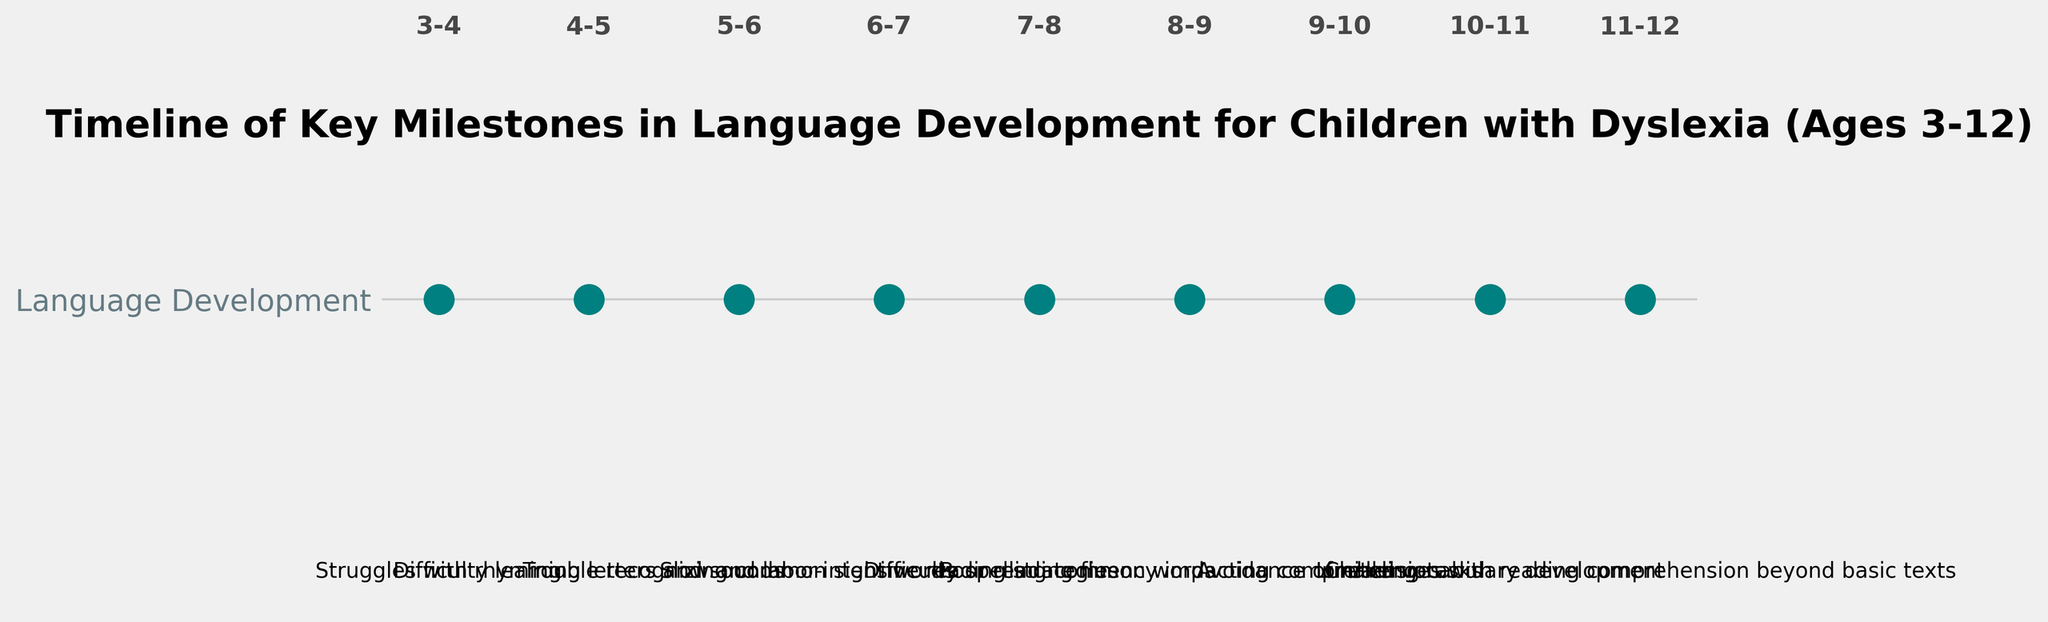When do children with dyslexia typically start struggling with rhyming? The figure shows that children with dyslexia usually start struggling with rhyming between the ages of 3 and 4. This is indicated by the milestone marker at the 3-4 age range.
Answer: Between ages 3-4 At what age do children with dyslexia commonly have difficulty learning letters and sounds? According to the figure, children with dyslexia often face issues learning letters and sounds between the ages of 4 and 5. The milestone for this is marked at the 4-5 age range.
Answer: Between ages 4-5 Which milestone related to reading strategies appears first on the timeline? The figure specifies a milestone referring to "slow and labor-intensive reading strategies" at the age range of 6-7, which is the first mention of reading strategies in the timeline.
Answer: Age 6-7 What is the primary reading challenge for children with dyslexia between ages 9 and 10, according to the timeline? The figure indicates that children with dyslexia primarily experience "Avoidance of reading tasks" between the ages of 9 and 10, as shown by the milestone for this age range.
Answer: Avoidance of reading tasks Compare the complexity of reading comprehension challenges between ages 8-9 and 11-12. The figure shows that from ages 8-9, children with dyslexia have "Poor reading fluency impacting comprehension," whereas from ages 11-12, they encounter "Challenges with reading comprehension beyond basic texts." The latter suggests a more advanced level of difficulty as it affects higher-level comprehension beyond basics.
Answer: More advanced at ages 11-12 How do the milestones relate to vocabulary development as per the timeline, and at what age does this occur? The timeline in the figure indicates that children with dyslexia face "Limited vocabulary development" at ages 10-11, highlighting a developmental milestone where vocabulary growth is particularly affected.
Answer: Age 10-11 Identify the milestone directly associated with difficulties in recognizing common sight words and indicate the relevant age range. The figure shows that the milestone "Trouble recognizing common sight words" is marked for children aged 5-6, indicating this age range for the associated difficulty.
Answer: Age 5-6 What visual cue is used to indicate milestones on the timeline, and how consistently are they placed? The milestones on the timeline are indicated using teal-colored circles (markers), and they are consistently placed along a single horizontal line representing language development milestones.
Answer: Teal circles, consistently on one line What does the milestone at ages 7-8 signify in the context of language development for children with dyslexia? According to the figure, the milestone at ages 7-8 signifies "Difficulty spelling common words," indicating a specific challenge in language development for children with dyslexia during this age range.
Answer: Difficulty spelling common words List all milestones related to reading challenges mentioned in the timeline. The figure lists several milestones related to reading challenges: 
(1) Trouble recognizing common sight words (age 5-6), 
(2) Slow and labor-intensive reading strategies (age 6-7), 
(3) Poor reading fluency impacting comprehension (age 8-9), 
(4) Avoidance of reading tasks (age 9-10), 
(5) Challenges with reading comprehension beyond basic texts (age 11-12).
Answer: Sight words (5-6), reading strategies (6-7), fluency (8-9), avoidance (9-10), and comprehension (11-12) 